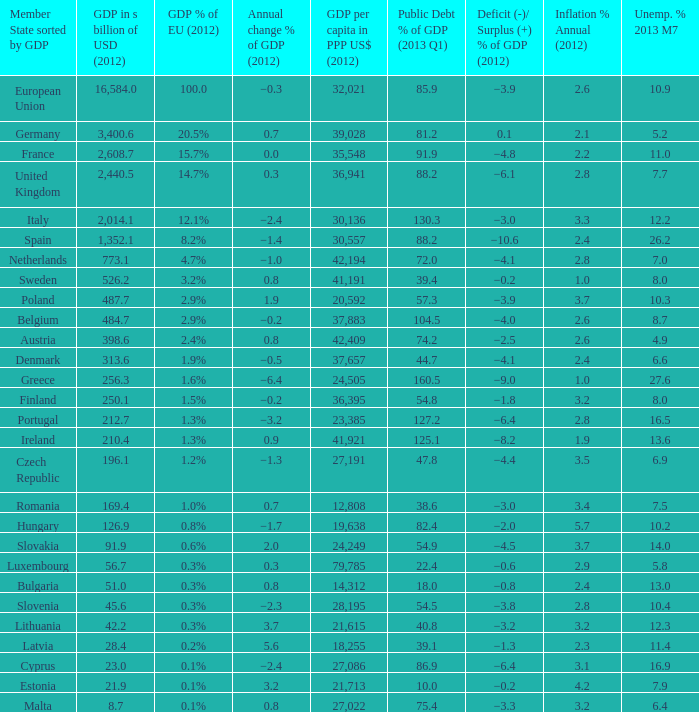4, and an inflation % yearly in 2012 of −0.6. 